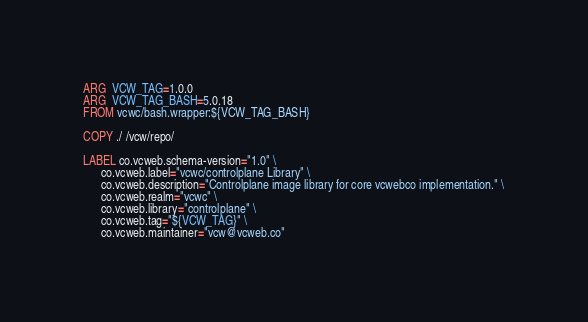<code> <loc_0><loc_0><loc_500><loc_500><_Dockerfile_>ARG  VCW_TAG=1.0.0
ARG  VCW_TAG_BASH=5.0.18
FROM vcwc/bash.wrapper:${VCW_TAG_BASH}

COPY ./ /vcw/repo/

LABEL co.vcweb.schema-version="1.0" \
      co.vcweb.label="vcwc/controlplane Library" \
      co.vcweb.description="Controlplane image library for core vcwebco implementation." \
      co.vcweb.realm="vcwc" \
      co.vcweb.library="controlplane" \
      co.vcweb.tag="${VCW_TAG}" \
      co.vcweb.maintainer="vcw@vcweb.co"
</code> 